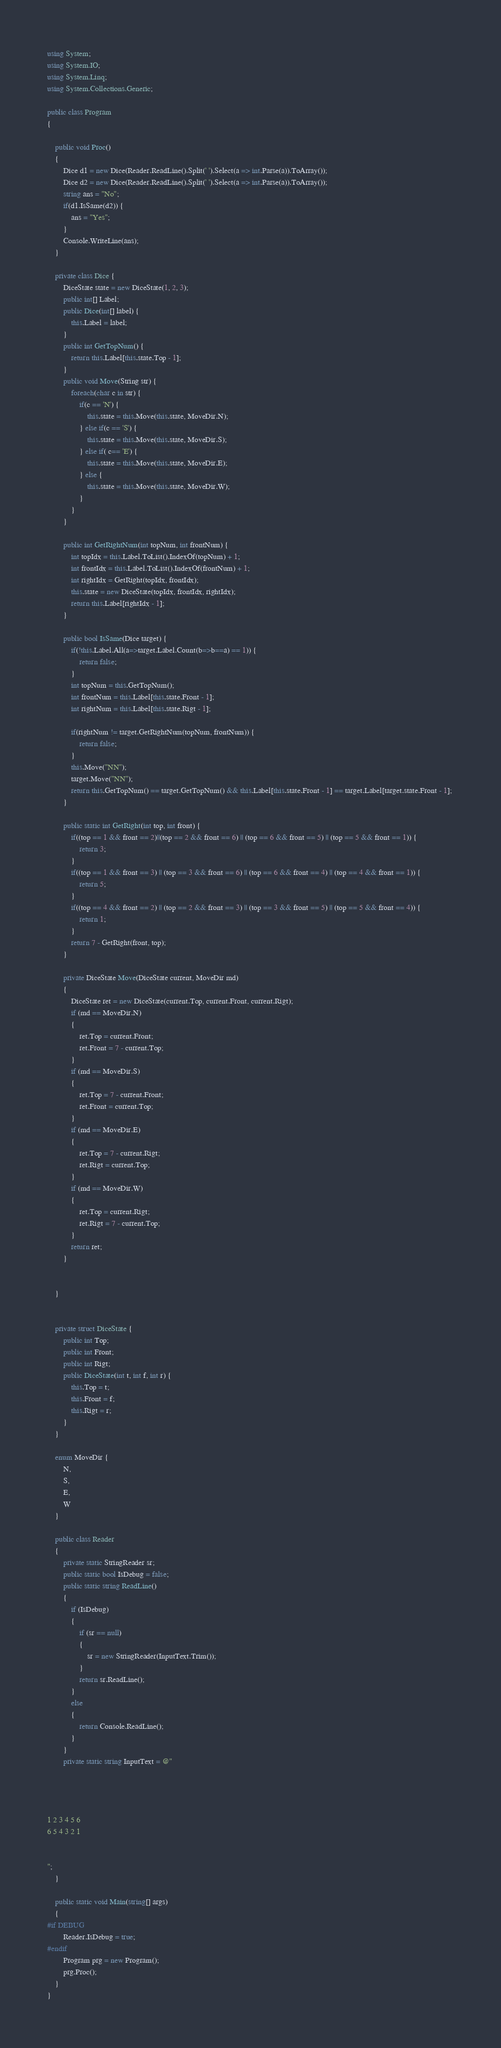<code> <loc_0><loc_0><loc_500><loc_500><_C#_>using System;
using System.IO;
using System.Linq;
using System.Collections.Generic;

public class Program
{

    public void Proc()
    {
        Dice d1 = new Dice(Reader.ReadLine().Split(' ').Select(a => int.Parse(a)).ToArray());
        Dice d2 = new Dice(Reader.ReadLine().Split(' ').Select(a => int.Parse(a)).ToArray());
        string ans = "No";
        if(d1.IsSame(d2)) {
            ans = "Yes";
        }
        Console.WriteLine(ans);
    }

    private class Dice {
        DiceState state = new DiceState(1, 2, 3);
        public int[] Label;
        public Dice(int[] label) {
            this.Label = label;
        }
        public int GetTopNum() {
            return this.Label[this.state.Top - 1];
        }
        public void Move(String str) {
            foreach(char c in str) {
                if(c == 'N') {
                    this.state = this.Move(this.state, MoveDir.N);
                } else if(c == 'S') {
                    this.state = this.Move(this.state, MoveDir.S);
                } else if( c== 'E') {
                    this.state = this.Move(this.state, MoveDir.E);
                } else {
                    this.state = this.Move(this.state, MoveDir.W);
				}
            }
        }

        public int GetRightNum(int topNum, int frontNum) {
            int topIdx = this.Label.ToList().IndexOf(topNum) + 1;
            int frontIdx = this.Label.ToList().IndexOf(frontNum) + 1;
            int rightIdx = GetRight(topIdx, frontIdx);
            this.state = new DiceState(topIdx, frontIdx, rightIdx);
            return this.Label[rightIdx - 1];
        }

        public bool IsSame(Dice target) {
            if(!this.Label.All(a=>target.Label.Count(b=>b==a) == 1)) {
                return false;
            }
            int topNum = this.GetTopNum();
            int frontNum = this.Label[this.state.Front - 1];
            int rightNum = this.Label[this.state.Rigt - 1];

            if(rightNum != target.GetRightNum(topNum, frontNum)) {
                return false;
            }
            this.Move("NN");
            target.Move("NN");
            return this.GetTopNum() == target.GetTopNum() && this.Label[this.state.Front - 1] == target.Label[target.state.Front - 1]; 
		}

        public static int GetRight(int top, int front) {
            if((top == 1 && front == 2)||(top == 2 && front == 6) || (top == 6 && front == 5) || (top == 5 && front == 1)) {
                return 3;
            }
            if((top == 1 && front == 3) || (top == 3 && front == 6) || (top == 6 && front == 4) || (top == 4 && front == 1)) {
                return 5;
            }
            if((top == 4 && front == 2) || (top == 2 && front == 3) || (top == 3 && front == 5) || (top == 5 && front == 4)) {
                return 1;
            }
            return 7 - GetRight(front, top);
		}

		private DiceState Move(DiceState current, MoveDir md)
		{
			DiceState ret = new DiceState(current.Top, current.Front, current.Rigt);
			if (md == MoveDir.N)
			{
				ret.Top = current.Front;
				ret.Front = 7 - current.Top;
			}
			if (md == MoveDir.S)
			{
				ret.Top = 7 - current.Front;
				ret.Front = current.Top;
			}
			if (md == MoveDir.E)
			{
				ret.Top = 7 - current.Rigt;
				ret.Rigt = current.Top;
			}
            if (md == MoveDir.W)
			{
				ret.Top = current.Rigt;
				ret.Rigt = 7 - current.Top;
			}
			return ret;
		}


	}


    private struct DiceState {
        public int Top;
        public int Front;
        public int Rigt;
        public DiceState(int t, int f, int r) {
            this.Top = t;
            this.Front = f;
            this.Rigt = r;
        }
    }

    enum MoveDir {
        N,
        S,
        E,
        W
    }

    public class Reader
	{
		private static StringReader sr;
		public static bool IsDebug = false;
		public static string ReadLine()
		{
			if (IsDebug)
			{
				if (sr == null)
				{
					sr = new StringReader(InputText.Trim());
				}
				return sr.ReadLine();
			}
			else
			{
				return Console.ReadLine();
			}
		}
		private static string InputText = @"




1 2 3 4 5 6
6 5 4 3 2 1


";
	}

	public static void Main(string[] args)
	{
#if DEBUG
		Reader.IsDebug = true;
#endif
		Program prg = new Program();
		prg.Proc();
	}
}</code> 